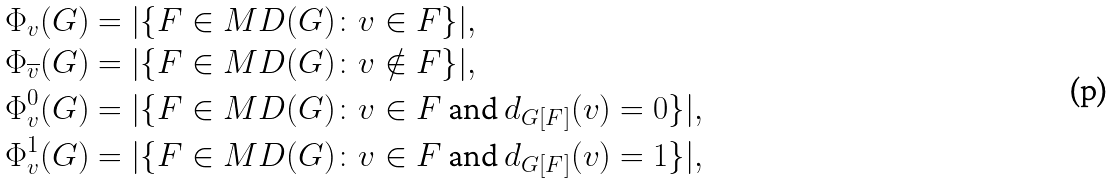<formula> <loc_0><loc_0><loc_500><loc_500>\Phi _ { v } ( G ) & = | \{ F \in M D ( G ) \colon v \in F \} | , \\ \Phi _ { \overline { v } } ( G ) & = | \{ F \in M D ( G ) \colon v \notin F \} | , \\ \Phi _ { v } ^ { 0 } ( G ) & = | \{ F \in M D ( G ) \colon v \in F \text { and } d _ { G [ F ] } ( v ) = 0 \} | , \\ \Phi _ { v } ^ { 1 } ( G ) & = | \{ F \in M D ( G ) \colon v \in F \text { and } d _ { G [ F ] } ( v ) = 1 \} | ,</formula> 